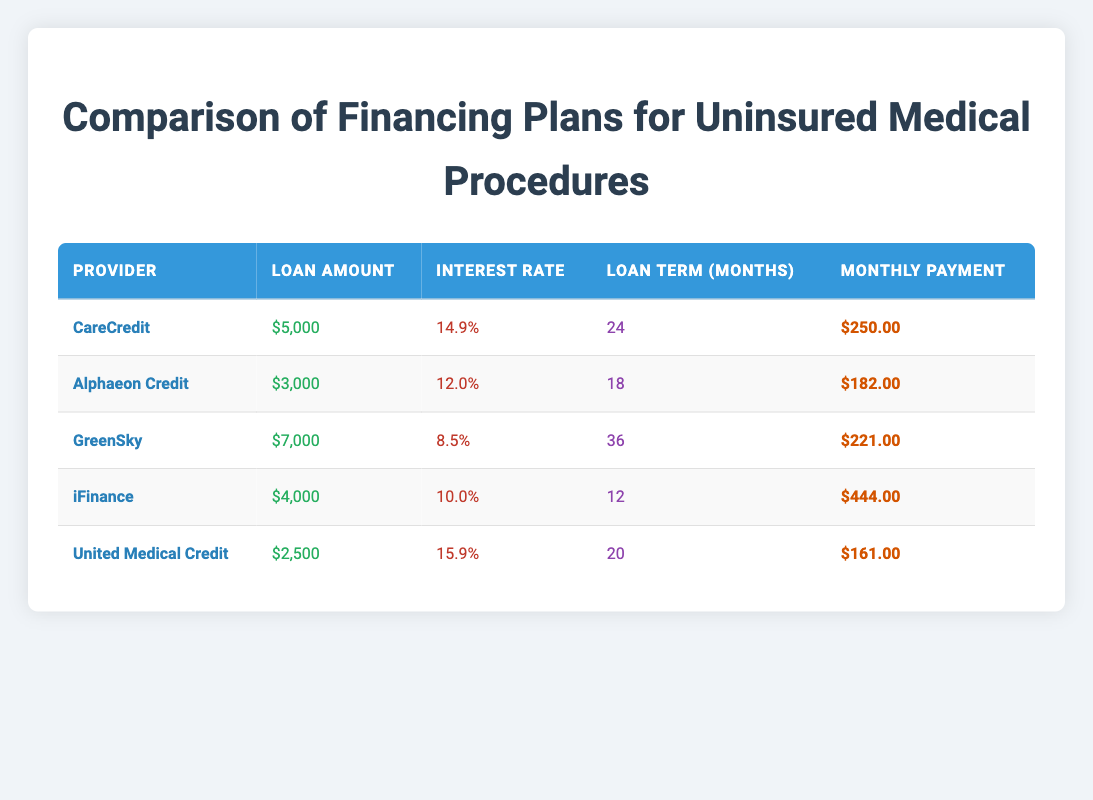What is the monthly payment for CareCredit? The monthly payment for CareCredit is directly shown in the table under the "Monthly Payment" column for CareCredit, which lists $250.00 as the value.
Answer: $250.00 Which provider has the highest interest rate? By examining the "Interest Rate" column for each provider, we see that United Medical Credit has 15.9%, which is higher than CareCredit (14.9%), Alphaeon Credit (12.0%), GreenSky (8.5%), and iFinance (10.0%).
Answer: United Medical Credit What is the total loan amount across all providers? To find the total loan amount, we sum up the loan amounts from all providers: $5000 + $3000 + $7000 + $4000 + $2500 = $22500.
Answer: $22500 Which financing plan requires the lowest monthly payment? The monthly payments for each provider are $250.00 for CareCredit, $182.00 for Alphaeon Credit, $221.00 for GreenSky, $444.00 for iFinance, and $161.00 for United Medical Credit. Comparing these values shows that United Medical Credit has the lowest at $161.00.
Answer: United Medical Credit What is the average monthly payment for the financing plans listed? To calculate the average monthly payment, we add the monthly payments together: $250.00 + $182.00 + $221.00 + $444.00 + $161.00 = $1258.00. Then, we divide this sum by the number of providers, which is 5, giving us an average monthly payment of $1258.00 / 5 = $251.60.
Answer: $251.60 Is the loan term for GreenSky longer than that of CareCredit? The loan term for GreenSky is 36 months while CareCredit has a term of 24 months. Since 36 is greater than 24, the answer is yes.
Answer: Yes Which two providers have a loan term of 24 months or less? By reviewing the "Loan Term (Months)" column, we see that CareCredit (24 months) and iFinance (12 months) have loan terms of 24 months or less.
Answer: CareCredit and iFinance What is the difference in monthly payments between the highest and lowest monthly payment providers? The highest monthly payment is from iFinance at $444.00, and the lowest is from United Medical Credit at $161.00. The difference is calculated by subtracting: $444.00 - $161.00 = $283.00.
Answer: $283.00 Which financing plan has the smallest loan amount and how much is it? By examining the "Loan Amount" column, United Medical Credit has the smallest loan amount of $2500, which is lower than the amounts from CareCredit, Alphaeon Credit, GreenSky, and iFinance.
Answer: $2500 